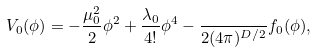Convert formula to latex. <formula><loc_0><loc_0><loc_500><loc_500>V _ { 0 } ( \phi ) = - \frac { \mu _ { 0 } ^ { 2 } } { 2 } \phi ^ { 2 } + \frac { \lambda _ { 0 } } { 4 ! } \phi ^ { 4 } - \frac { } { 2 ( 4 \pi ) ^ { D / 2 } } f _ { 0 } ( \phi ) ,</formula> 